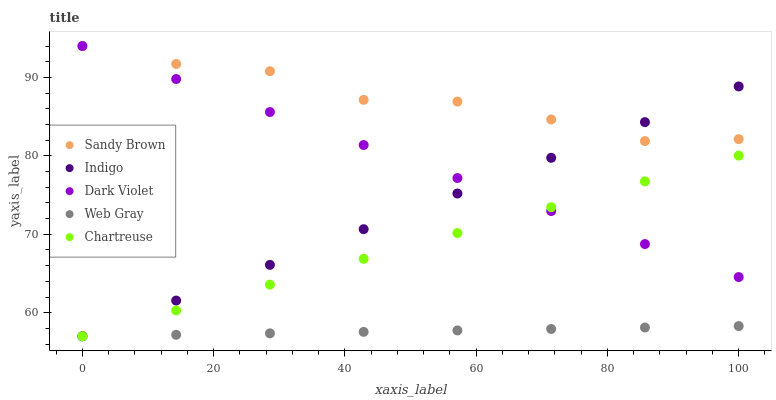Does Web Gray have the minimum area under the curve?
Answer yes or no. Yes. Does Sandy Brown have the maximum area under the curve?
Answer yes or no. Yes. Does Chartreuse have the minimum area under the curve?
Answer yes or no. No. Does Chartreuse have the maximum area under the curve?
Answer yes or no. No. Is Chartreuse the smoothest?
Answer yes or no. Yes. Is Sandy Brown the roughest?
Answer yes or no. Yes. Is Web Gray the smoothest?
Answer yes or no. No. Is Web Gray the roughest?
Answer yes or no. No. Does Indigo have the lowest value?
Answer yes or no. Yes. Does Sandy Brown have the lowest value?
Answer yes or no. No. Does Dark Violet have the highest value?
Answer yes or no. Yes. Does Chartreuse have the highest value?
Answer yes or no. No. Is Web Gray less than Sandy Brown?
Answer yes or no. Yes. Is Sandy Brown greater than Chartreuse?
Answer yes or no. Yes. Does Web Gray intersect Chartreuse?
Answer yes or no. Yes. Is Web Gray less than Chartreuse?
Answer yes or no. No. Is Web Gray greater than Chartreuse?
Answer yes or no. No. Does Web Gray intersect Sandy Brown?
Answer yes or no. No. 